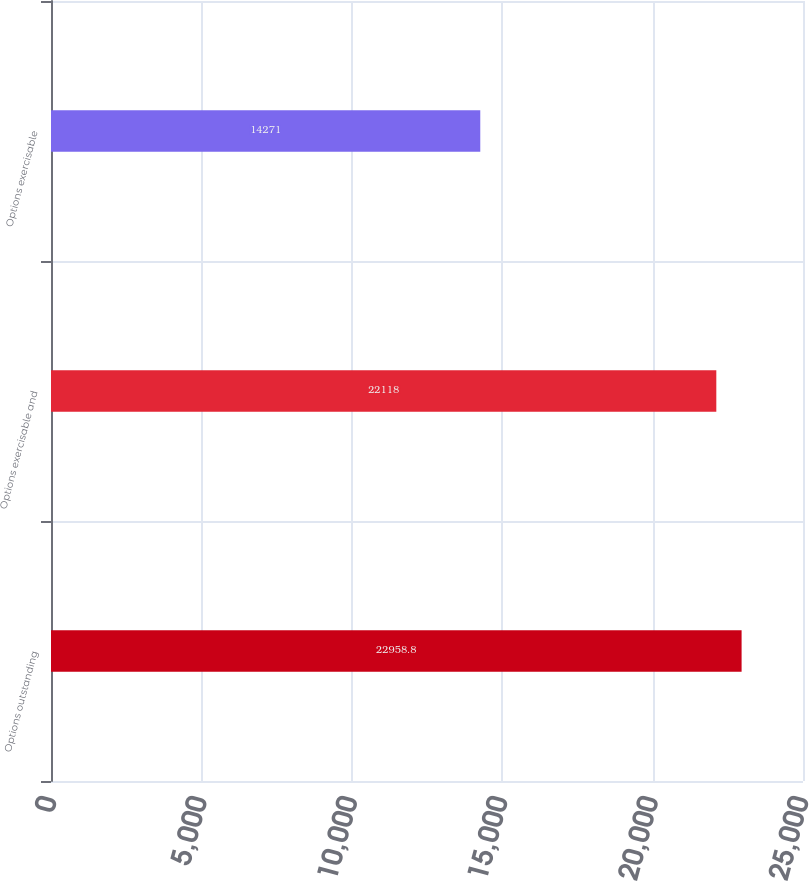<chart> <loc_0><loc_0><loc_500><loc_500><bar_chart><fcel>Options outstanding<fcel>Options exercisable and<fcel>Options exercisable<nl><fcel>22958.8<fcel>22118<fcel>14271<nl></chart> 